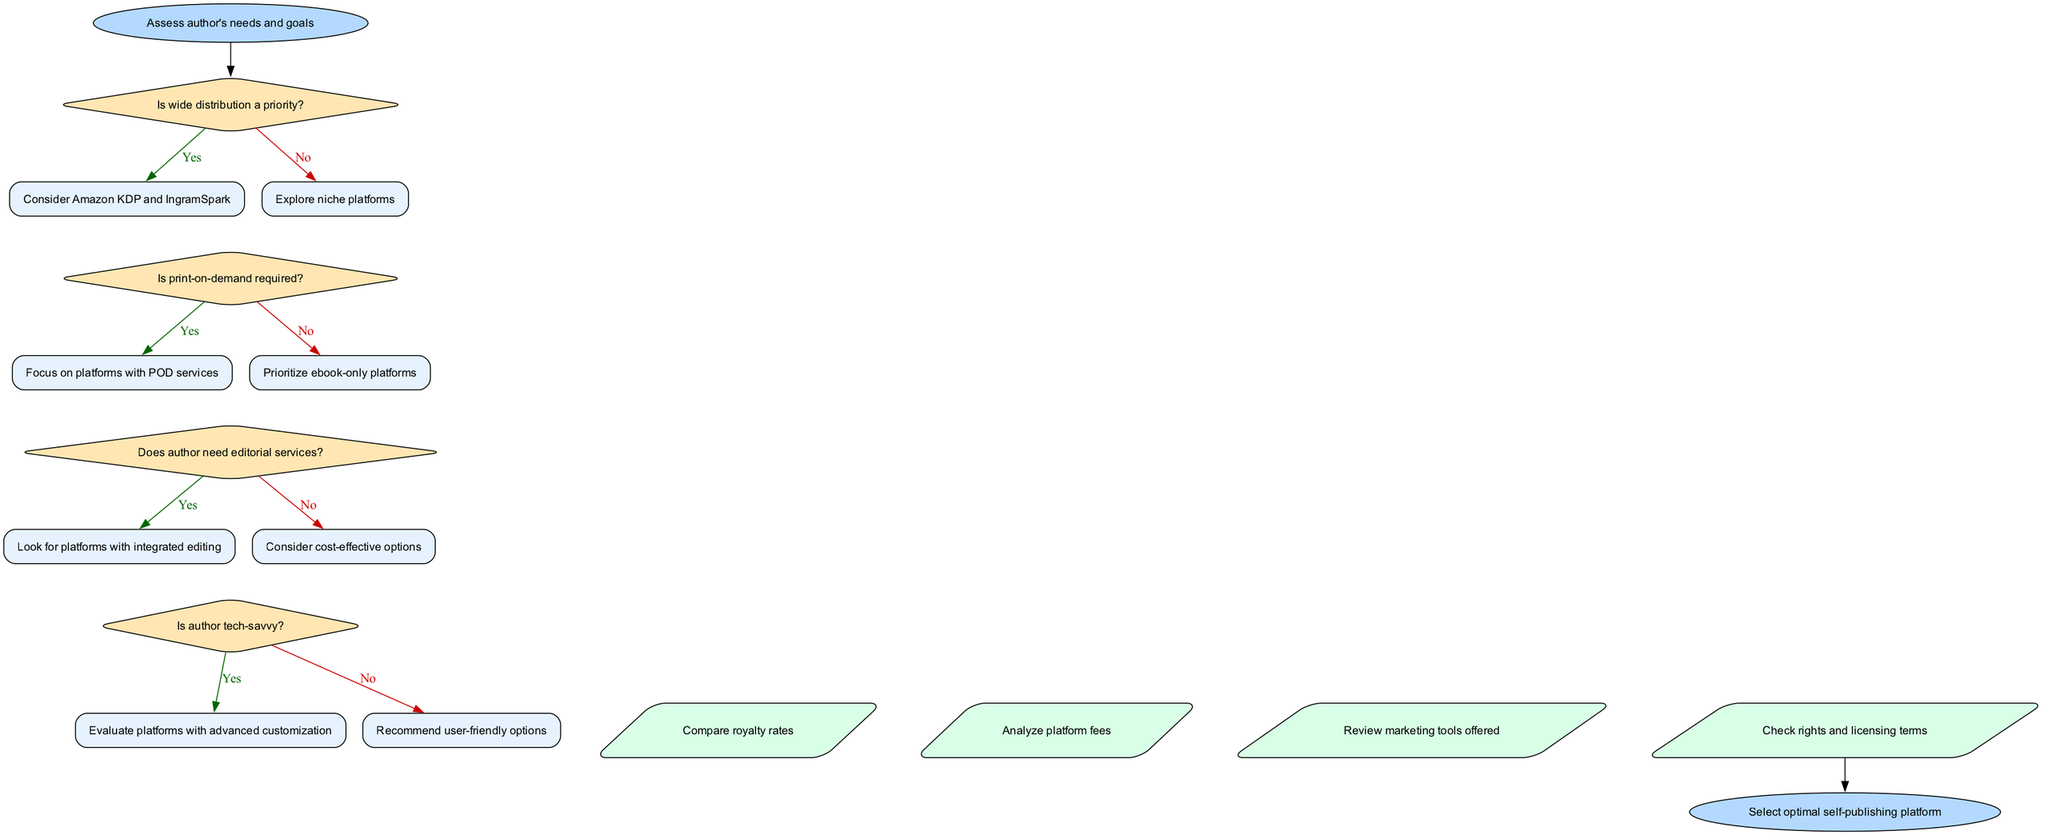What is the starting point of the diagram? The starting point is labeled as "Assess author's needs and goals." This is clearly indicated at the top of the flowchart.
Answer: Assess author's needs and goals How many decision nodes are there in the diagram? There are four decision nodes present in the flowchart, each representing a question regarding the author's needs and preferences.
Answer: 4 What is the first question asked in the decision-making process? The first question in the decision-making process is "Is wide distribution a priority?" This is the initial decision node in the flowchart.
Answer: Is wide distribution a priority? If the answer to the third decision question is "yes," what action should be taken next? If the answer to "Does author need editorial services?" is "yes," the flow directs to "Look for platforms with integrated editing." This is a direct consequence of that decision node.
Answer: Look for platforms with integrated editing What is the final outcome of following the flowchart? The final outcome, as indicated in the last node, is to "Select optimal self-publishing platform." This is the endpoint of the flowchart's decision-making process.
Answer: Select optimal self-publishing platform If the author is not tech-savvy, which platforms should be recommended? If the author is not tech-savvy, the recommendation is to "Recommend user-friendly options." This conclusion is reached from the second-to-last decision node.
Answer: Recommend user-friendly options What are the first two actions to take after the last decision point? The first two actions after the last decision point are to "Compare royalty rates" and "Analyze platform fees." These are linked sequentially as actions that follow the decision-making process.
Answer: Compare royalty rates, Analyze platform fees Which platform is suggested if wide distribution is a priority? If wide distribution is prioritized, the suggestion is to "Consider Amazon KDP and IngramSpark." This is depicted directly at the decision point related to distribution.
Answer: Consider Amazon KDP and IngramSpark 